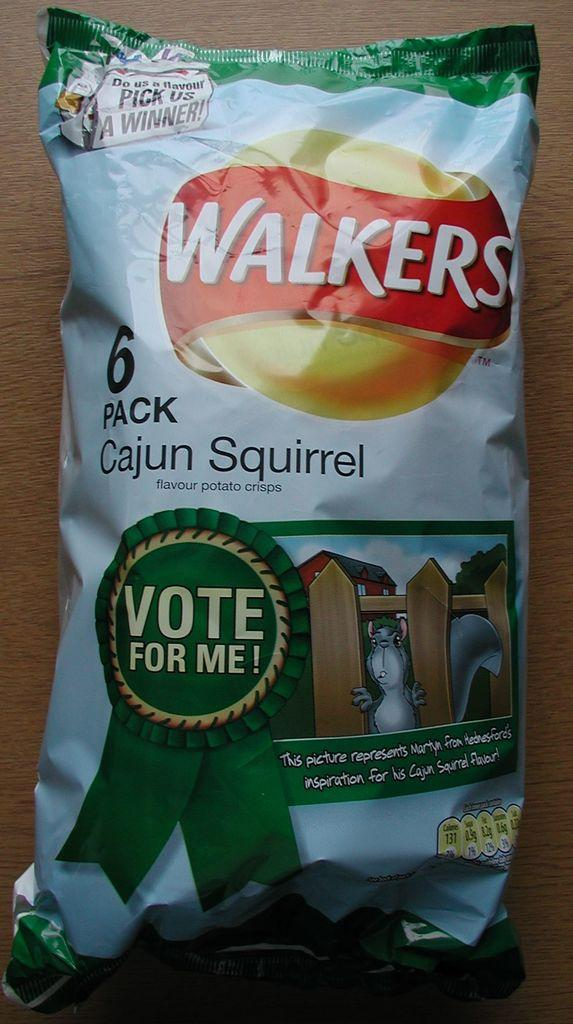What is present on the desk in the image? There is a snacks packet on the desk in the image. What type of yarn is being used to create the flame on the desk in the image? There is no yarn or flame present in the image; it only features a snacks packet on a desk. 